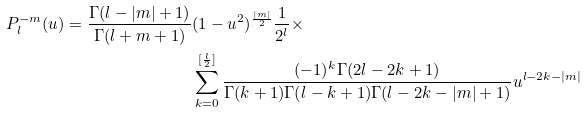Convert formula to latex. <formula><loc_0><loc_0><loc_500><loc_500>P _ { l } ^ { - m } ( u ) = \frac { \Gamma ( l - | m | + 1 ) } { \Gamma ( l + m + 1 ) } & ( 1 - u ^ { 2 } ) ^ { \frac { | m | } { 2 } } \frac { 1 } { 2 ^ { l } } \times \\ & \sum _ { k = 0 } ^ { [ \frac { l } { 2 } ] } \frac { ( - 1 ) ^ { k } \Gamma ( 2 l - 2 k + 1 ) } { \Gamma ( k + 1 ) \Gamma ( l - k + 1 ) \Gamma ( l - 2 k - | m | + 1 ) } u ^ { l - 2 k - | m | } \\</formula> 